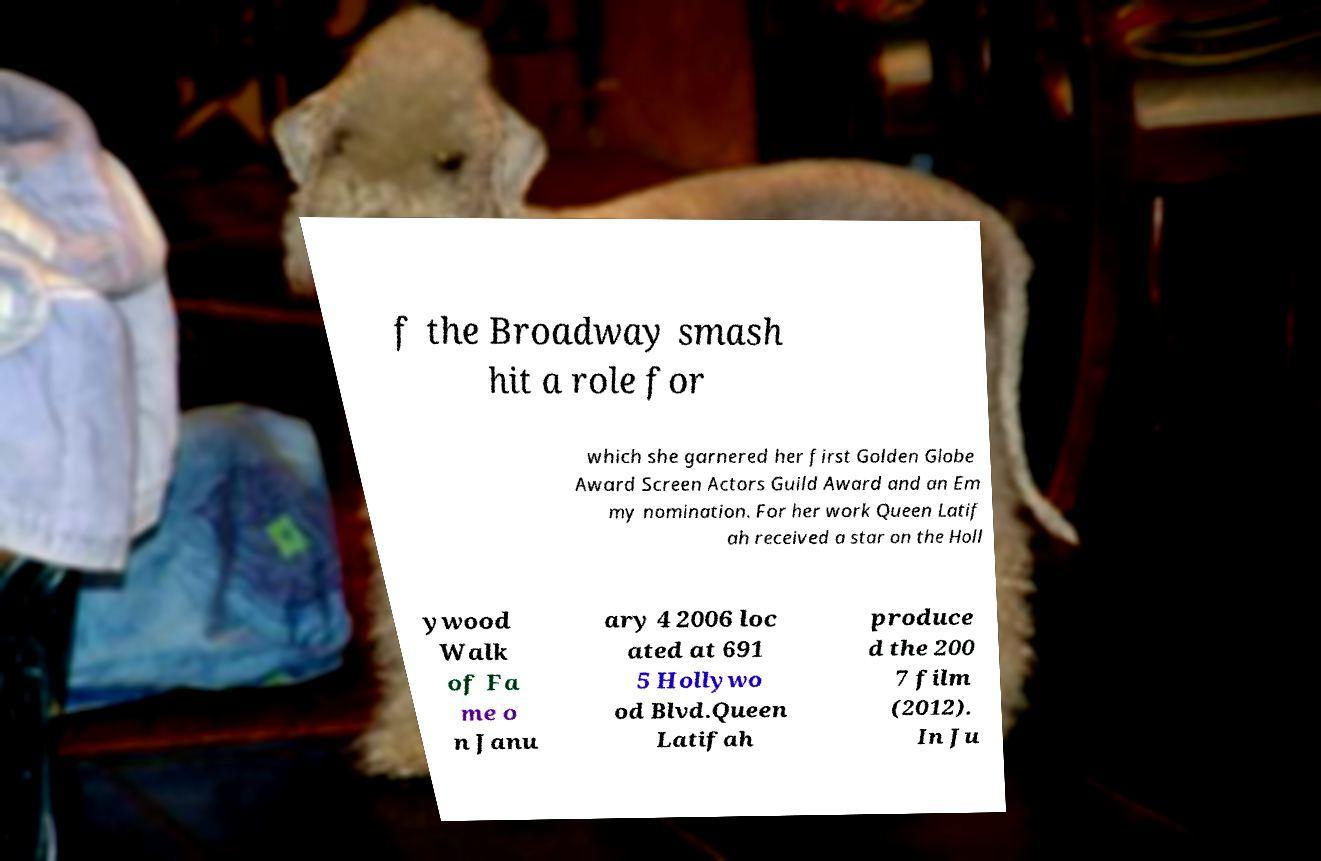Can you read and provide the text displayed in the image?This photo seems to have some interesting text. Can you extract and type it out for me? f the Broadway smash hit a role for which she garnered her first Golden Globe Award Screen Actors Guild Award and an Em my nomination. For her work Queen Latif ah received a star on the Holl ywood Walk of Fa me o n Janu ary 4 2006 loc ated at 691 5 Hollywo od Blvd.Queen Latifah produce d the 200 7 film (2012). In Ju 